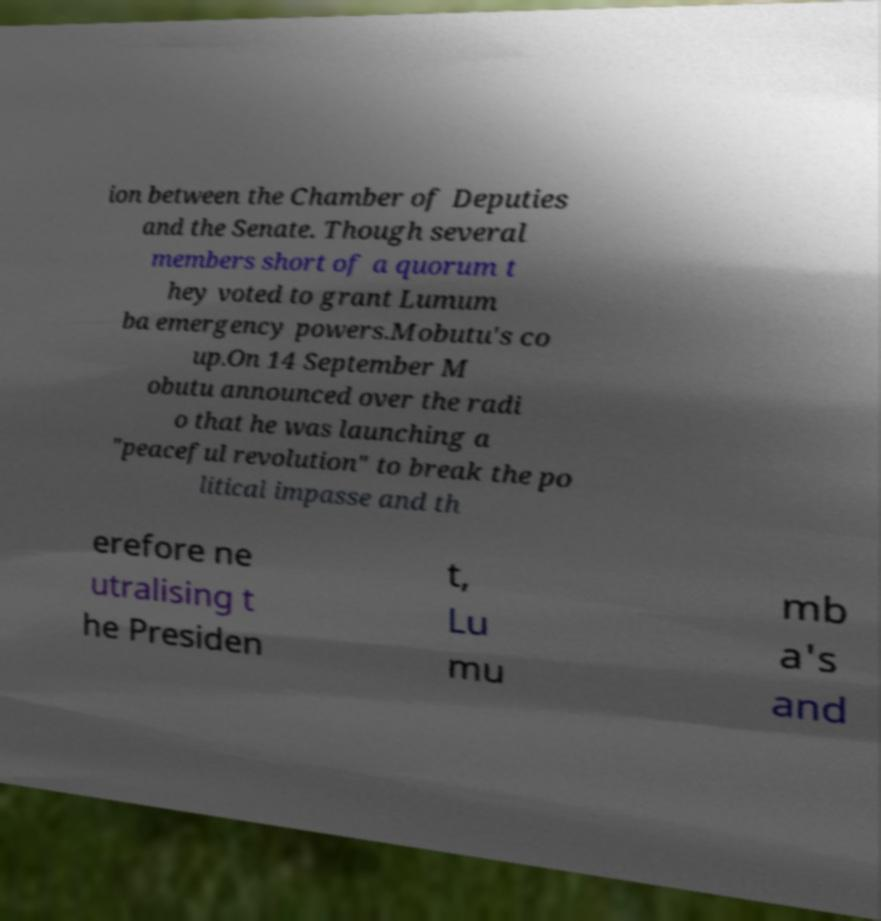Please identify and transcribe the text found in this image. ion between the Chamber of Deputies and the Senate. Though several members short of a quorum t hey voted to grant Lumum ba emergency powers.Mobutu's co up.On 14 September M obutu announced over the radi o that he was launching a "peaceful revolution" to break the po litical impasse and th erefore ne utralising t he Presiden t, Lu mu mb a's and 